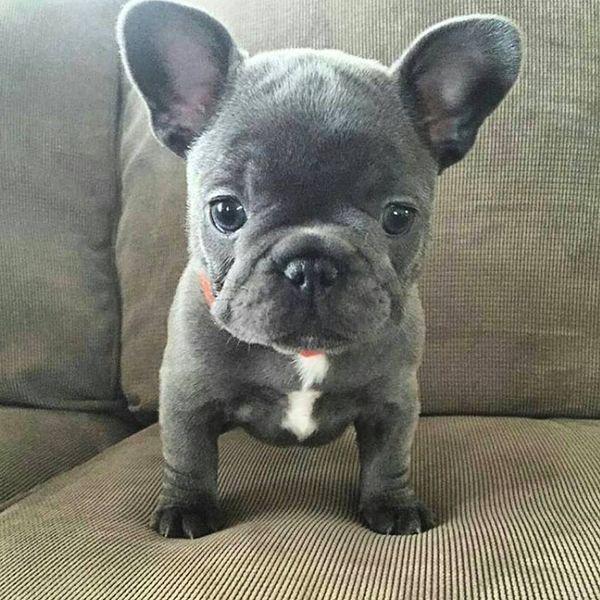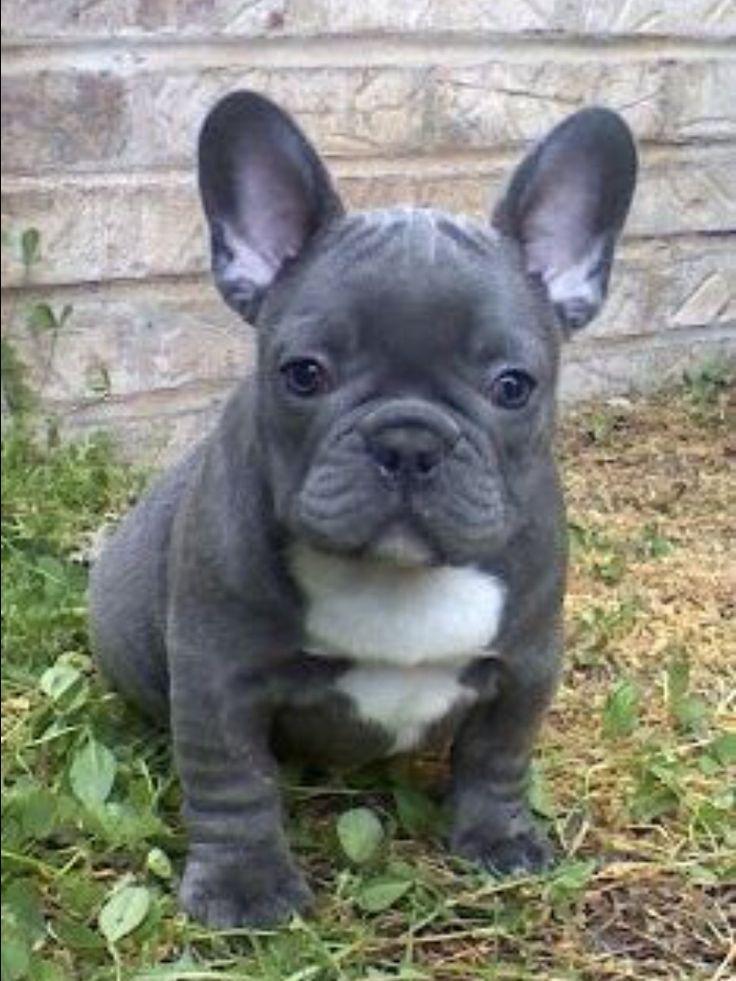The first image is the image on the left, the second image is the image on the right. Considering the images on both sides, is "The dog in the right image has its mouth open and its tongue out." valid? Answer yes or no. No. The first image is the image on the left, the second image is the image on the right. Analyze the images presented: Is the assertion "A dog is standing on grass in one image and a dog is on the couch in the other." valid? Answer yes or no. Yes. 